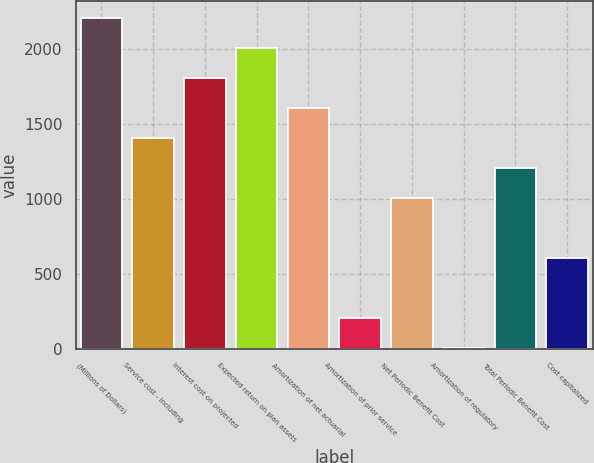<chart> <loc_0><loc_0><loc_500><loc_500><bar_chart><fcel>(Millions of Dollars)<fcel>Service cost - including<fcel>Interest cost on projected<fcel>Expected return on plan assets<fcel>Amortization of net actuarial<fcel>Amortization of prior service<fcel>Net Periodic Benefit Cost<fcel>Amortization of regulatory<fcel>Total Periodic Benefit Cost<fcel>Cost capitalized<nl><fcel>2207.3<fcel>1406.1<fcel>1806.7<fcel>2007<fcel>1606.4<fcel>204.3<fcel>1005.5<fcel>4<fcel>1205.8<fcel>604.9<nl></chart> 